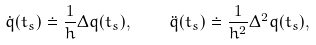Convert formula to latex. <formula><loc_0><loc_0><loc_500><loc_500>\dot { q } ( t _ { s } ) \doteq \frac { 1 } { h } \Delta q ( t _ { s } ) , \quad \ddot { q } ( t _ { s } ) \doteq \frac { 1 } { h ^ { 2 } } \Delta ^ { 2 } q ( t _ { s } ) ,</formula> 